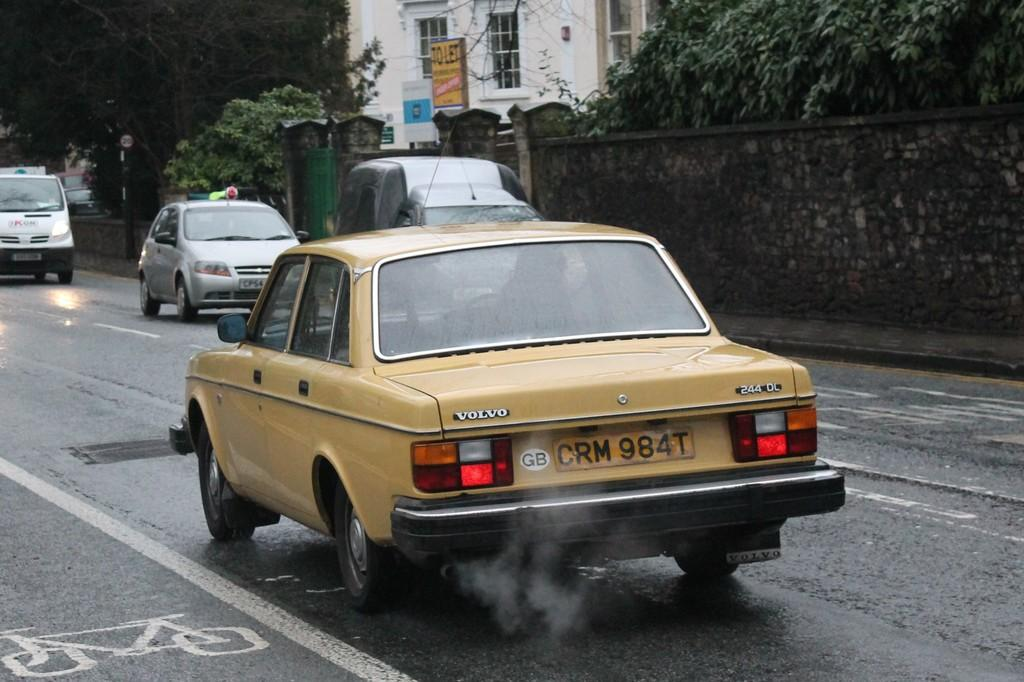What can be seen on the road in the image? There are vehicles on the road in the image. What is located behind the vehicles in the image? There is a wall visible in the image. What type of vegetation is present in the image? There are trees in the image. What is the purpose of the signboard in the image? The purpose of the signboard in the image is to provide information or directions. What is the structure with windows in the image? There is a building with windows in the image. What type of heart can be seen beating in the image? There is no heart visible in the image; it features vehicles on the road, a wall, trees, a signboard, and a building with windows. Is there a rifle present in the image? No, there is no rifle present in the image. 